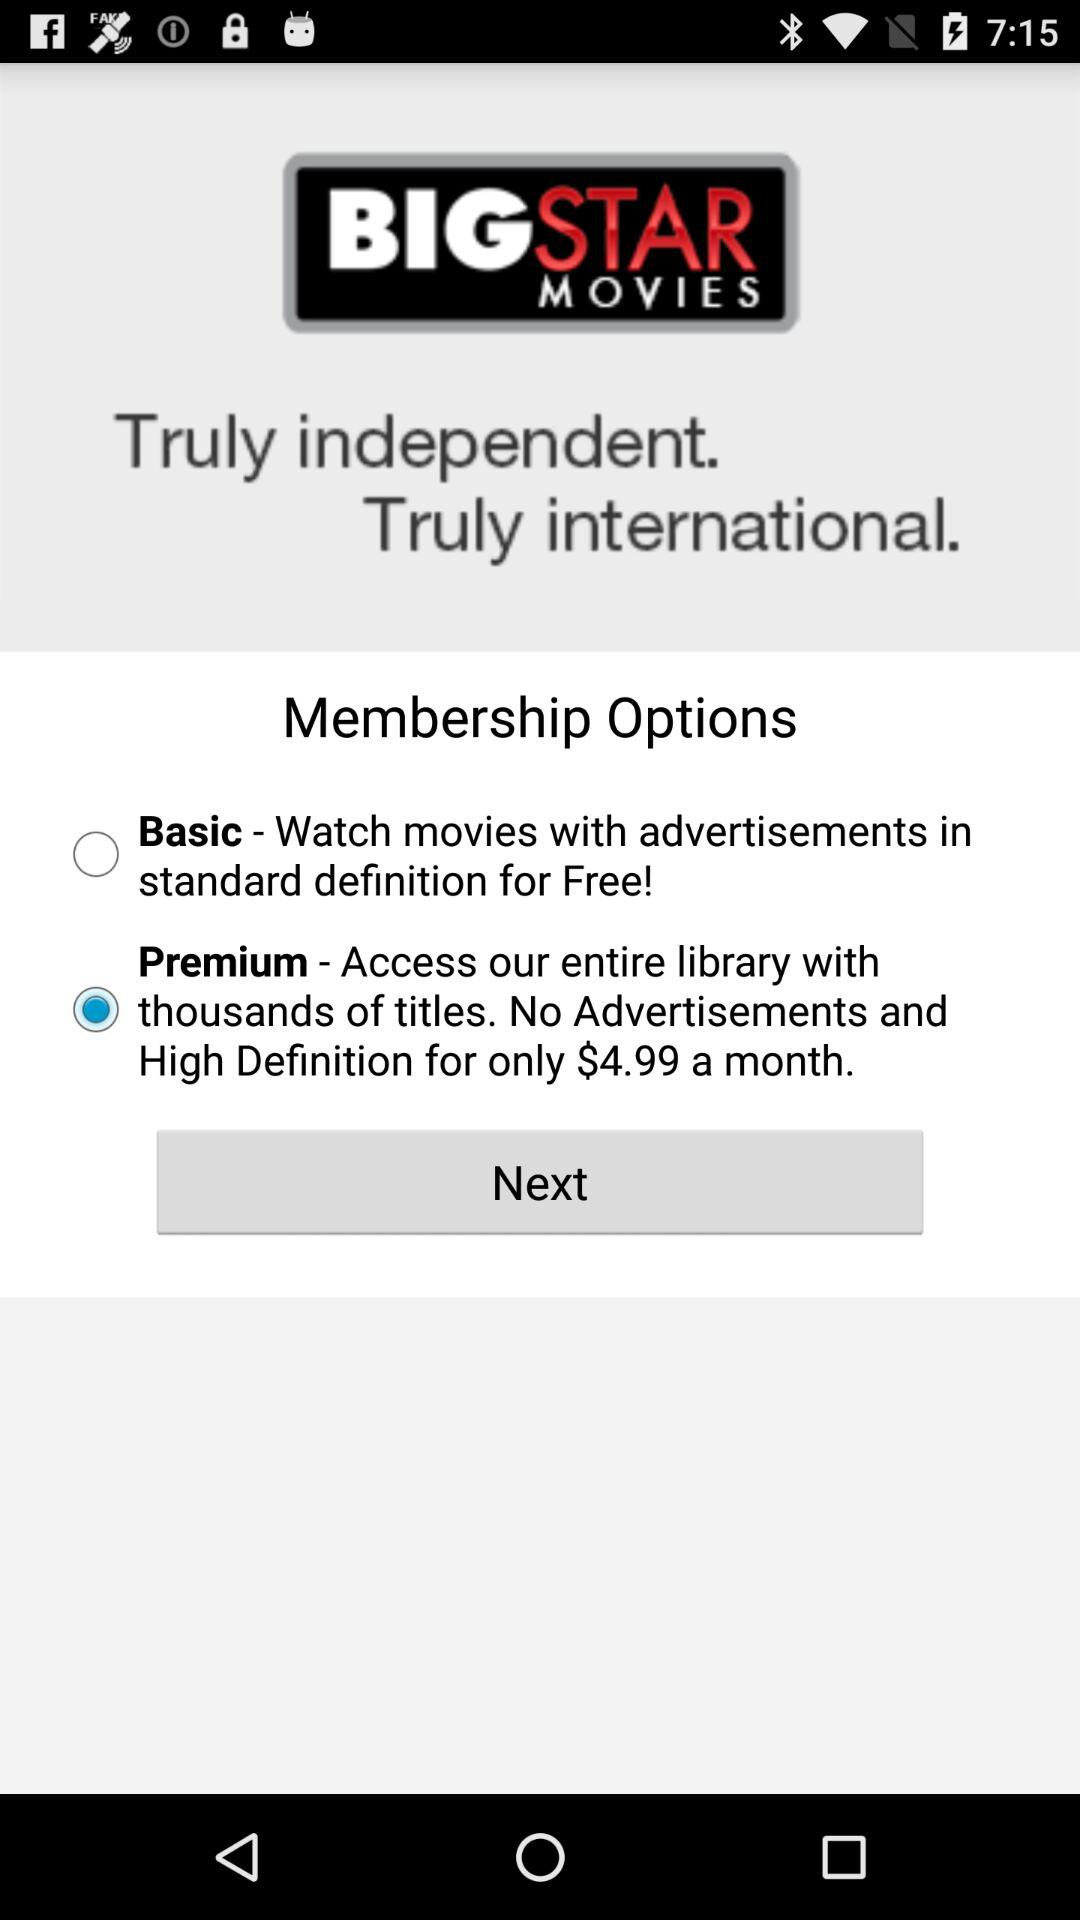Can you tell me about the company offering these memberships? Based on the image, the company offering these memberships is 'BIG STAR MOVIES' which brands itself as 'Truly independent. Truly international.' This suggests a focus on a diverse range of films, possibly including independent and international selections. Are there any other visible features in the image that can provide more information? The image shows a user interface with a 'Next' button, suggesting this is part of a sign-up process or a step in selecting a membership. However, no additional context or feature is discernible beyond what is related to the membership selection. 